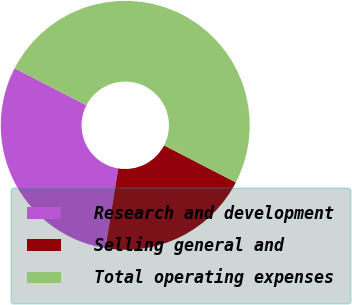Convert chart. <chart><loc_0><loc_0><loc_500><loc_500><pie_chart><fcel>Research and development<fcel>Selling general and<fcel>Total operating expenses<nl><fcel>30.03%<fcel>19.97%<fcel>50.0%<nl></chart> 